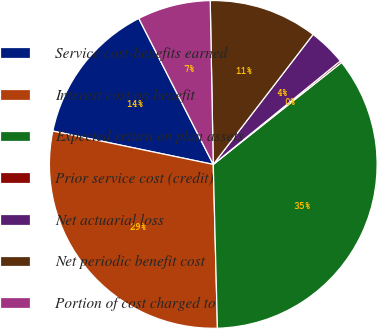Convert chart to OTSL. <chart><loc_0><loc_0><loc_500><loc_500><pie_chart><fcel>Service cost-benefits earned<fcel>Interest cost on benefit<fcel>Expected return on plan assets<fcel>Prior service cost (credit)<fcel>Net actuarial loss<fcel>Net periodic benefit cost<fcel>Portion of cost charged to<nl><fcel>14.23%<fcel>28.67%<fcel>35.28%<fcel>0.19%<fcel>3.7%<fcel>10.72%<fcel>7.21%<nl></chart> 